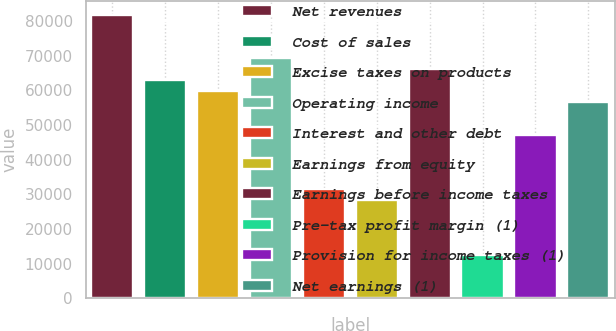<chart> <loc_0><loc_0><loc_500><loc_500><bar_chart><fcel>Net revenues<fcel>Cost of sales<fcel>Excise taxes on products<fcel>Operating income<fcel>Interest and other debt<fcel>Earnings from equity<fcel>Earnings before income taxes<fcel>Pre-tax profit margin (1)<fcel>Provision for income taxes (1)<fcel>Net earnings (1)<nl><fcel>81791<fcel>62916.5<fcel>59770.7<fcel>69208<fcel>31459<fcel>28313.2<fcel>66062.2<fcel>12584.5<fcel>47187.7<fcel>56625<nl></chart> 